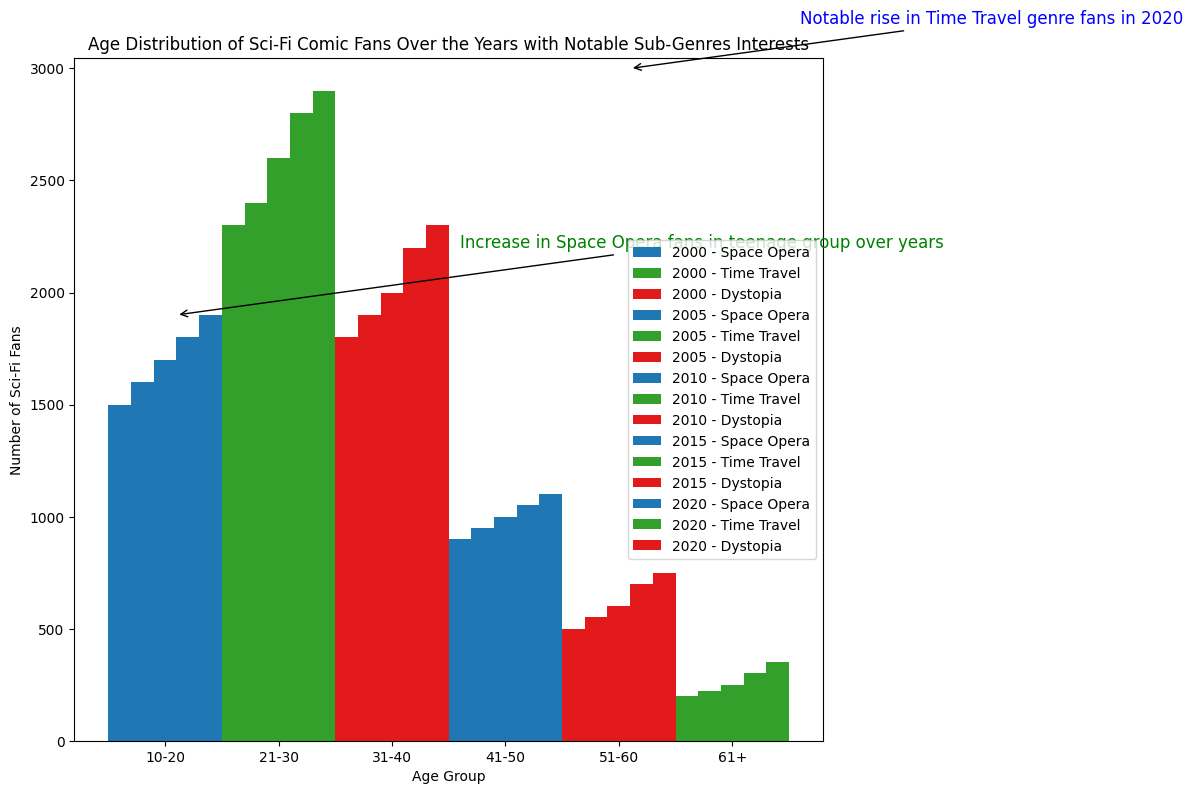How does the number of Sci-Fi fans aged 10-20 change from 2000 to 2020? Examine the height of the bars corresponding to the 10-20 age group for each year. In 2000, the bar is at 1500 fans. By 2020, it has risen to 1900 fans. The number increases over these years.
Answer: The number increases from 1500 to 1900 Which age group has the highest increase in Time Travel fans from 2000 to 2020? Compare the height differences of the bars related to Time Travel fans in 2000 and 2020 for each age group. For the 21-30 age group, the number of fans increases from 2300 in 2000 to 2900 in 2020, which is the highest increase of 600 fans.
Answer: The 21-30 age group In 2015, which sub-genre had the least number of fans in the 41-50 age group? Look at the bars for the 41-50 age group in the 2015 year. The bar is labeled for Space Opera with 1050 fans. Since it's the only sub-genre listed for this age group, it has the least fans, answering our question based on the provided sub-genre.
Answer: Space Opera Compare the number of Dystopia fans aged 31-40 in 2000 and 2020. Which year had more fans? Find the height of the bars for Dystopia fans in the 31-40 age group for the years 2000 and 2020. In 2000, there are 1800 fans, while in 2020, there are 2300 fans. Thus, 2020 had more fans.
Answer: 2020 had more fans How do the Sci-Fi fan numbers in the 51-60 age group compare between the years 2010 and 2020 for Dystopia fans? Check the bar heights of 51-60-age group Dystopia fans in 2010 and 2020. There are 600 fans in 2010 and 750 fans in 2020.
Answer: Fans increased from 600 to 750 Which year had the smallest number of Space Opera fans aged 10-20? Review the bars for the 10-20 age group categorized under Space Opera across all years. In the year 2000, the number of fans is 1500, which is the smallest compared to other years.
Answer: 2000 What is the sum of the number of Sci-Fi fans aged 61+ in 2000 and 2015? Add the height of the bars representing the 61+ age group in 2000 and 2015. In 2000, there are 200 fans, and in 2015, there are 300 fans. The sum is 200 + 300 = 500.
Answer: 500 Which age group showed the most significant increase in Sci-Fi fans, looking at fans of all sub-genres, from 2000 to 2020? Compare the total bar heights for each age group across all sub-genres between 2000 and 2020. The 21-30 age group shows an increase from 2300 in 2000 to 2900 in 2020, marking the most significant increase of 600 fans.
Answer: The 21-30 age group 